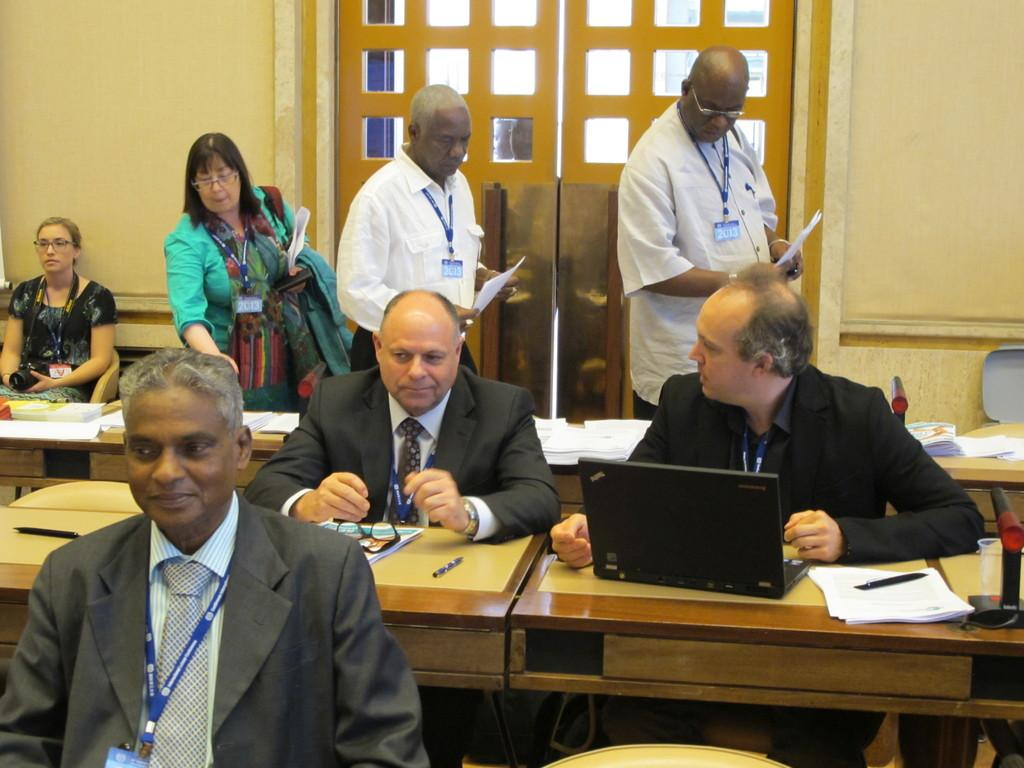What is the color of the wall in the image? The wall in the image is yellow. What is located on the wall? There is a door on the wall in the image. Who or what can be seen in the image? There are people present in the image. What type of furniture is visible in the image? Chairs and tables are present in the image. What items are on the tables? Papers, spectacles, pens, and a laptop are on the tables. Reasoning: Let' Let's think step by step in order to produce the conversation. We start by identifying the main subject in the image, which is the yellow wall. Then, we expand the conversation to include other items that are also visible, such as the door, people, furniture, and items on the tables. Each question is designed to elicit a specific detail about the image that is known from the provided facts. Absurd Question/Answer: What type of cork can be seen on the wall in the image? There is no cork present on the wall in the image; it is a yellow color wall with a door. What scent can be detected from the people in the image? There is no information about the scent of the people in the image, as we cannot detect scents through a visual medium. 